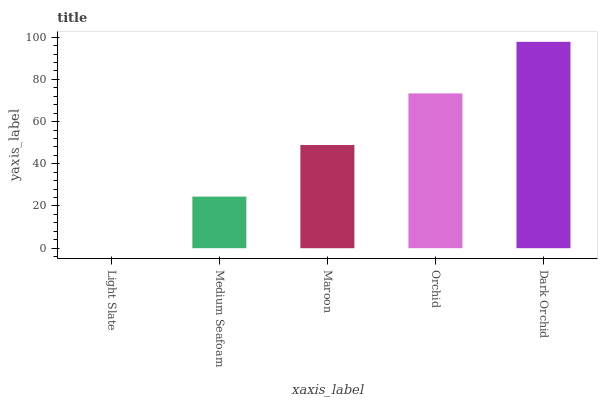Is Medium Seafoam the minimum?
Answer yes or no. No. Is Medium Seafoam the maximum?
Answer yes or no. No. Is Medium Seafoam greater than Light Slate?
Answer yes or no. Yes. Is Light Slate less than Medium Seafoam?
Answer yes or no. Yes. Is Light Slate greater than Medium Seafoam?
Answer yes or no. No. Is Medium Seafoam less than Light Slate?
Answer yes or no. No. Is Maroon the high median?
Answer yes or no. Yes. Is Maroon the low median?
Answer yes or no. Yes. Is Orchid the high median?
Answer yes or no. No. Is Light Slate the low median?
Answer yes or no. No. 